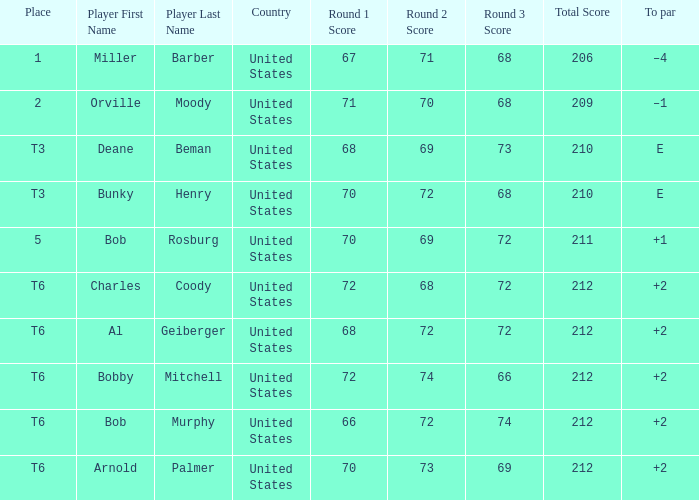What is the score of player bob rosburg? 70-69-72=211. 